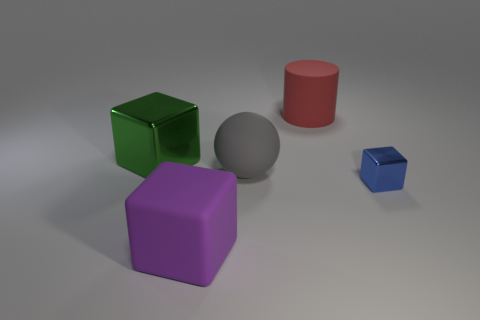Do the red thing and the shiny object to the right of the purple matte block have the same shape?
Make the answer very short. No. There is a block that is on the right side of the green block and behind the big rubber cube; what size is it?
Keep it short and to the point. Small. How many gray matte balls are there?
Ensure brevity in your answer.  1. There is a gray thing that is the same size as the red matte object; what is its material?
Provide a short and direct response. Rubber. Are there any blue metallic things of the same size as the blue cube?
Provide a short and direct response. No. There is a shiny cube right of the big purple rubber cube; is its color the same as the large object that is behind the big shiny block?
Provide a short and direct response. No. What number of metal objects are either large balls or big blue things?
Offer a very short reply. 0. There is a big rubber object that is behind the block that is behind the large gray rubber sphere; how many big red matte cylinders are to the left of it?
Ensure brevity in your answer.  0. There is a cylinder that is made of the same material as the gray thing; what is its size?
Your response must be concise. Large. How many other objects are the same color as the tiny object?
Provide a succinct answer. 0. 